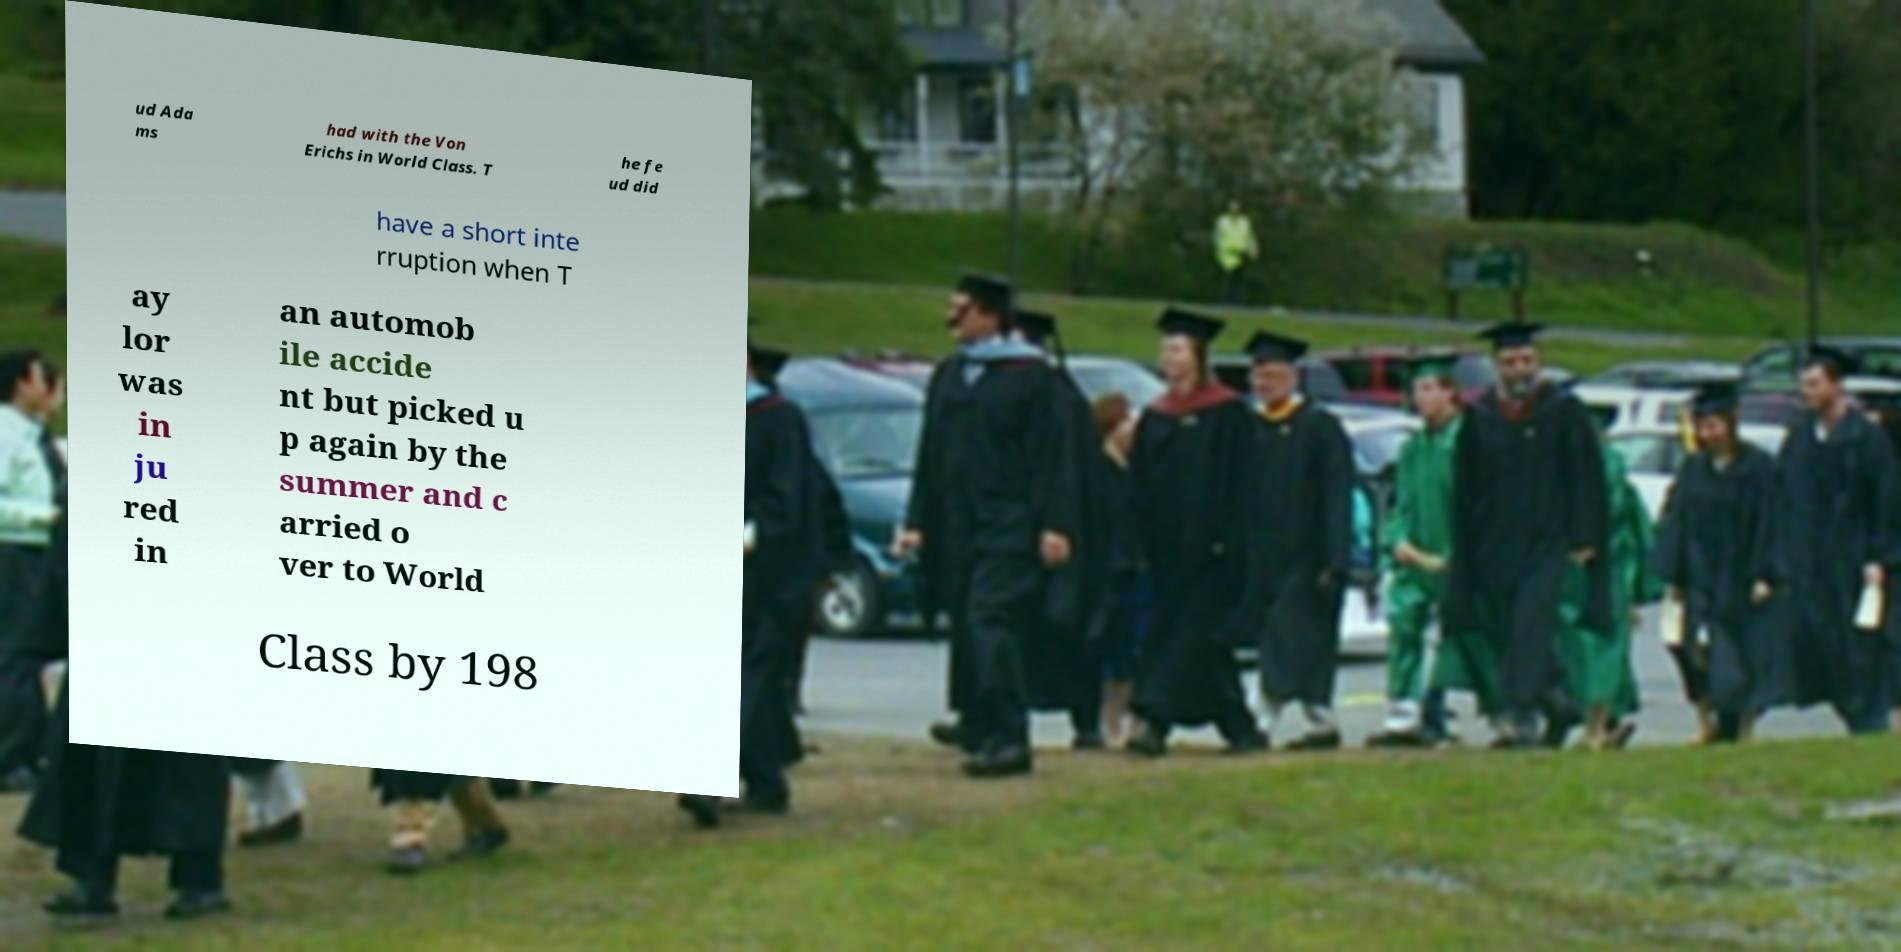There's text embedded in this image that I need extracted. Can you transcribe it verbatim? ud Ada ms had with the Von Erichs in World Class. T he fe ud did have a short inte rruption when T ay lor was in ju red in an automob ile accide nt but picked u p again by the summer and c arried o ver to World Class by 198 